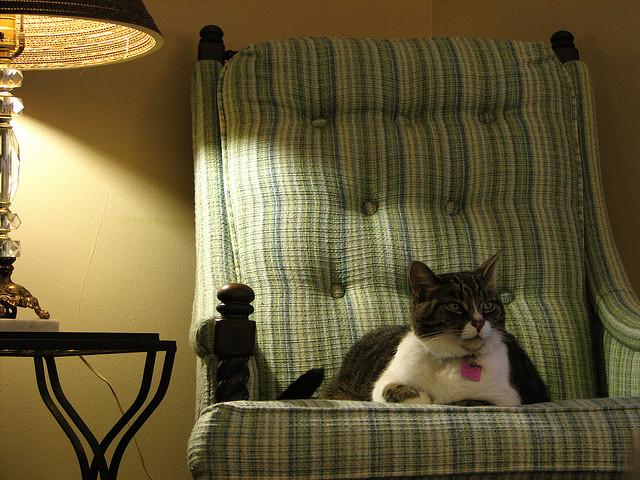Is the cat sleeping?
Quick response, please. No. What is the cat sitting on?
Answer briefly. Chair. What is putting light in the room?
Give a very brief answer. Lamp. 